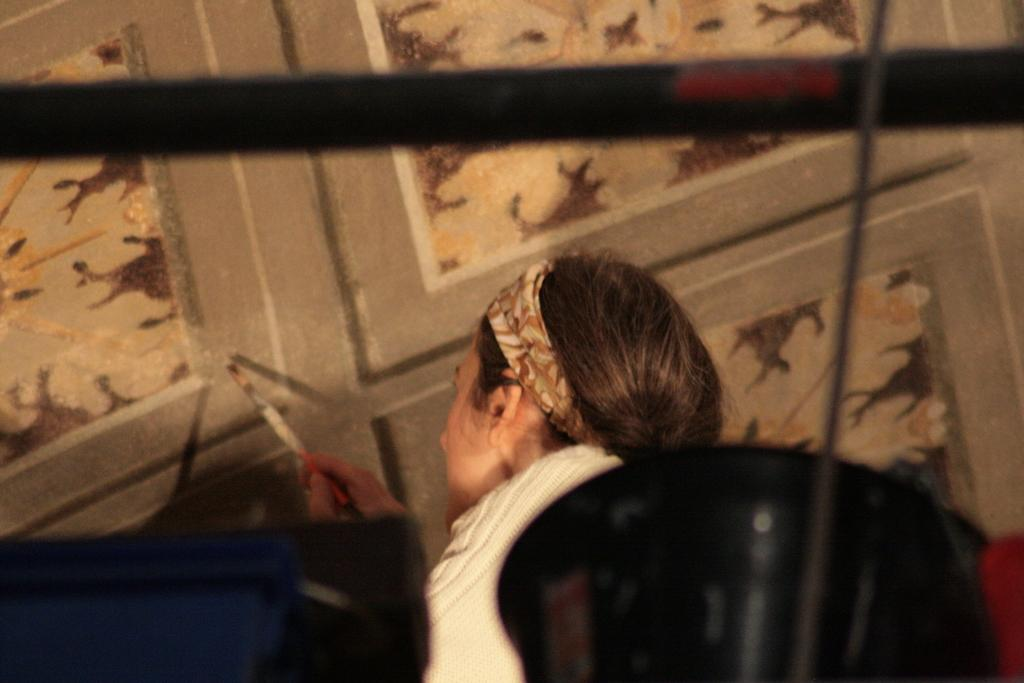Who is the main subject in the image? There is a person in the center of the image. What is the person holding in the image? The person is holding a brush. What can be seen in the background of the image? There is a wall visible in the background of the image. What is located at the bottom of the image? There are objects present at the bottom of the image. What language is the person speaking in the image? There is no indication of the person speaking in the image, so it cannot be determined what language they might be using. 